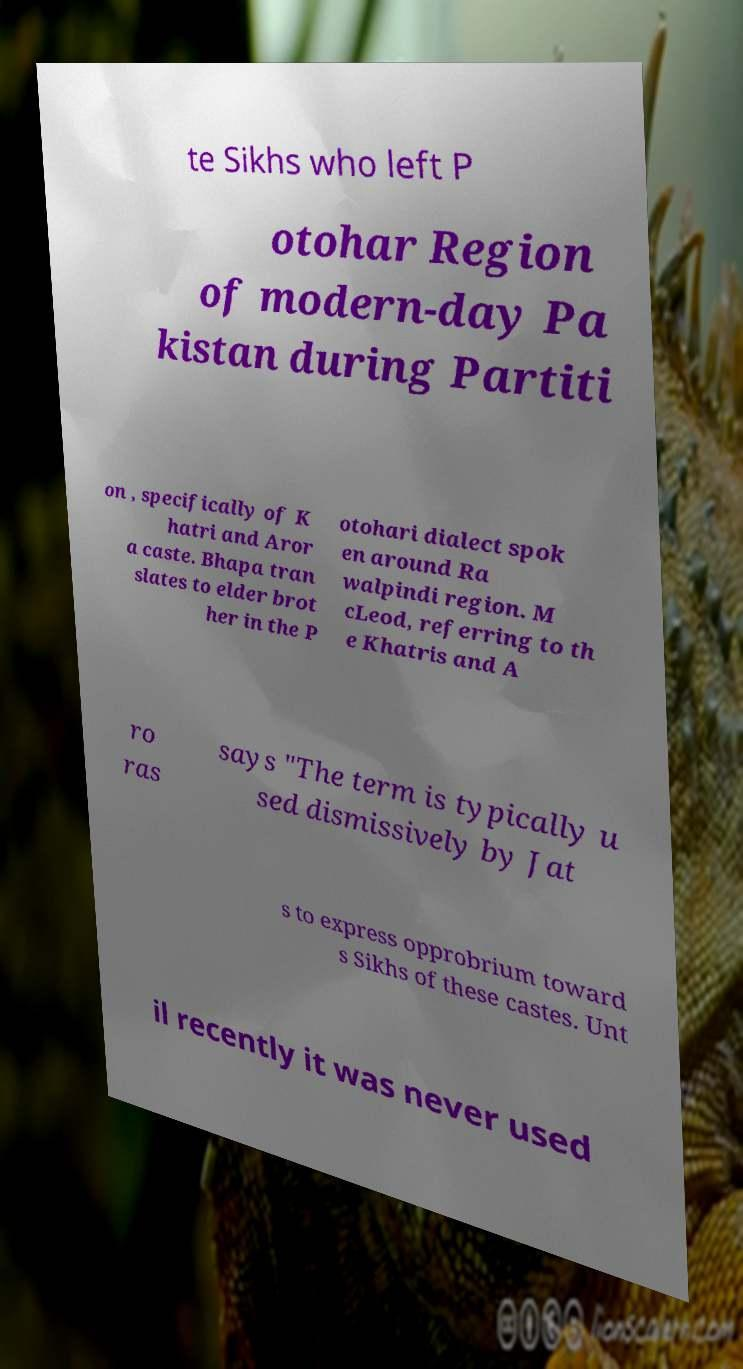Could you assist in decoding the text presented in this image and type it out clearly? te Sikhs who left P otohar Region of modern-day Pa kistan during Partiti on , specifically of K hatri and Aror a caste. Bhapa tran slates to elder brot her in the P otohari dialect spok en around Ra walpindi region. M cLeod, referring to th e Khatris and A ro ras says "The term is typically u sed dismissively by Jat s to express opprobrium toward s Sikhs of these castes. Unt il recently it was never used 